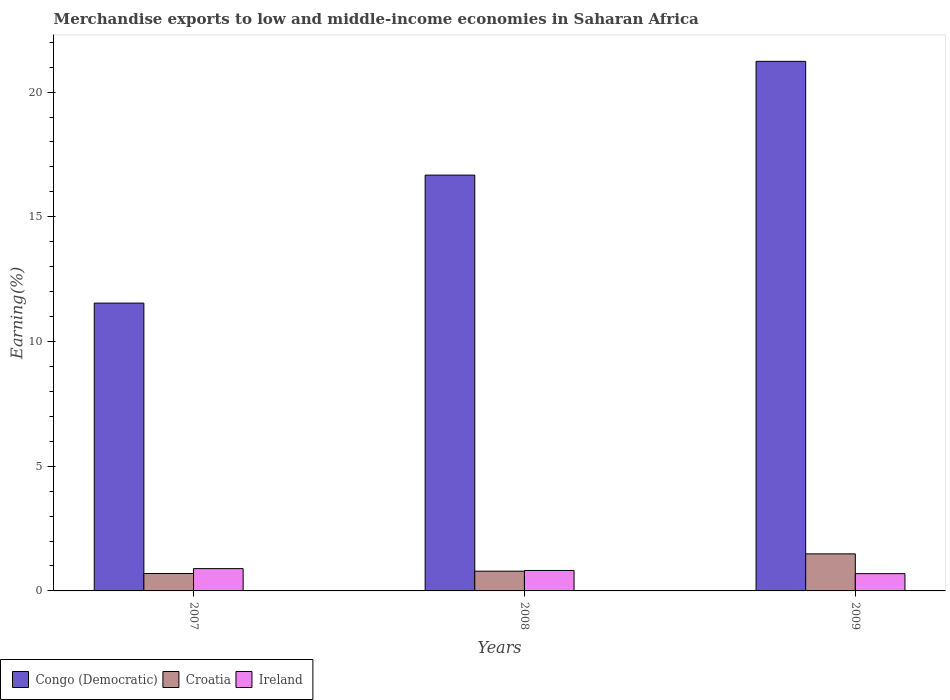How many groups of bars are there?
Your answer should be very brief. 3. Are the number of bars per tick equal to the number of legend labels?
Your answer should be very brief. Yes. Are the number of bars on each tick of the X-axis equal?
Your response must be concise. Yes. How many bars are there on the 1st tick from the left?
Offer a terse response. 3. How many bars are there on the 1st tick from the right?
Give a very brief answer. 3. What is the label of the 1st group of bars from the left?
Ensure brevity in your answer.  2007. In how many cases, is the number of bars for a given year not equal to the number of legend labels?
Make the answer very short. 0. What is the percentage of amount earned from merchandise exports in Congo (Democratic) in 2007?
Ensure brevity in your answer.  11.54. Across all years, what is the maximum percentage of amount earned from merchandise exports in Croatia?
Provide a short and direct response. 1.49. Across all years, what is the minimum percentage of amount earned from merchandise exports in Croatia?
Provide a short and direct response. 0.7. What is the total percentage of amount earned from merchandise exports in Congo (Democratic) in the graph?
Make the answer very short. 49.45. What is the difference between the percentage of amount earned from merchandise exports in Congo (Democratic) in 2007 and that in 2009?
Offer a terse response. -9.69. What is the difference between the percentage of amount earned from merchandise exports in Ireland in 2007 and the percentage of amount earned from merchandise exports in Congo (Democratic) in 2009?
Provide a short and direct response. -20.34. What is the average percentage of amount earned from merchandise exports in Croatia per year?
Give a very brief answer. 0.99. In the year 2007, what is the difference between the percentage of amount earned from merchandise exports in Croatia and percentage of amount earned from merchandise exports in Congo (Democratic)?
Make the answer very short. -10.84. What is the ratio of the percentage of amount earned from merchandise exports in Croatia in 2007 to that in 2009?
Offer a very short reply. 0.47. Is the percentage of amount earned from merchandise exports in Ireland in 2007 less than that in 2008?
Ensure brevity in your answer.  No. Is the difference between the percentage of amount earned from merchandise exports in Croatia in 2007 and 2008 greater than the difference between the percentage of amount earned from merchandise exports in Congo (Democratic) in 2007 and 2008?
Offer a very short reply. Yes. What is the difference between the highest and the second highest percentage of amount earned from merchandise exports in Ireland?
Your answer should be very brief. 0.07. What is the difference between the highest and the lowest percentage of amount earned from merchandise exports in Congo (Democratic)?
Your answer should be compact. 9.69. Is the sum of the percentage of amount earned from merchandise exports in Ireland in 2007 and 2009 greater than the maximum percentage of amount earned from merchandise exports in Congo (Democratic) across all years?
Provide a short and direct response. No. What does the 3rd bar from the left in 2009 represents?
Give a very brief answer. Ireland. What does the 1st bar from the right in 2008 represents?
Provide a succinct answer. Ireland. Is it the case that in every year, the sum of the percentage of amount earned from merchandise exports in Croatia and percentage of amount earned from merchandise exports in Congo (Democratic) is greater than the percentage of amount earned from merchandise exports in Ireland?
Keep it short and to the point. Yes. How many bars are there?
Make the answer very short. 9. Are all the bars in the graph horizontal?
Provide a short and direct response. No. How many years are there in the graph?
Provide a succinct answer. 3. Are the values on the major ticks of Y-axis written in scientific E-notation?
Keep it short and to the point. No. Does the graph contain any zero values?
Keep it short and to the point. No. Where does the legend appear in the graph?
Offer a very short reply. Bottom left. How many legend labels are there?
Offer a very short reply. 3. How are the legend labels stacked?
Your answer should be very brief. Horizontal. What is the title of the graph?
Keep it short and to the point. Merchandise exports to low and middle-income economies in Saharan Africa. Does "Kazakhstan" appear as one of the legend labels in the graph?
Offer a very short reply. No. What is the label or title of the X-axis?
Provide a succinct answer. Years. What is the label or title of the Y-axis?
Offer a terse response. Earning(%). What is the Earning(%) in Congo (Democratic) in 2007?
Provide a succinct answer. 11.54. What is the Earning(%) in Croatia in 2007?
Offer a terse response. 0.7. What is the Earning(%) in Ireland in 2007?
Offer a terse response. 0.89. What is the Earning(%) in Congo (Democratic) in 2008?
Ensure brevity in your answer.  16.67. What is the Earning(%) of Croatia in 2008?
Give a very brief answer. 0.79. What is the Earning(%) in Ireland in 2008?
Your response must be concise. 0.82. What is the Earning(%) of Congo (Democratic) in 2009?
Offer a terse response. 21.23. What is the Earning(%) in Croatia in 2009?
Provide a short and direct response. 1.49. What is the Earning(%) in Ireland in 2009?
Your response must be concise. 0.69. Across all years, what is the maximum Earning(%) of Congo (Democratic)?
Your answer should be very brief. 21.23. Across all years, what is the maximum Earning(%) in Croatia?
Provide a short and direct response. 1.49. Across all years, what is the maximum Earning(%) of Ireland?
Your response must be concise. 0.89. Across all years, what is the minimum Earning(%) in Congo (Democratic)?
Ensure brevity in your answer.  11.54. Across all years, what is the minimum Earning(%) of Croatia?
Provide a succinct answer. 0.7. Across all years, what is the minimum Earning(%) of Ireland?
Make the answer very short. 0.69. What is the total Earning(%) in Congo (Democratic) in the graph?
Your answer should be compact. 49.45. What is the total Earning(%) in Croatia in the graph?
Provide a succinct answer. 2.97. What is the total Earning(%) in Ireland in the graph?
Make the answer very short. 2.41. What is the difference between the Earning(%) in Congo (Democratic) in 2007 and that in 2008?
Ensure brevity in your answer.  -5.13. What is the difference between the Earning(%) in Croatia in 2007 and that in 2008?
Offer a very short reply. -0.09. What is the difference between the Earning(%) of Ireland in 2007 and that in 2008?
Keep it short and to the point. 0.07. What is the difference between the Earning(%) in Congo (Democratic) in 2007 and that in 2009?
Your answer should be compact. -9.69. What is the difference between the Earning(%) of Croatia in 2007 and that in 2009?
Keep it short and to the point. -0.79. What is the difference between the Earning(%) of Ireland in 2007 and that in 2009?
Your answer should be compact. 0.2. What is the difference between the Earning(%) of Congo (Democratic) in 2008 and that in 2009?
Your answer should be very brief. -4.56. What is the difference between the Earning(%) in Croatia in 2008 and that in 2009?
Make the answer very short. -0.69. What is the difference between the Earning(%) of Ireland in 2008 and that in 2009?
Offer a terse response. 0.13. What is the difference between the Earning(%) in Congo (Democratic) in 2007 and the Earning(%) in Croatia in 2008?
Ensure brevity in your answer.  10.75. What is the difference between the Earning(%) of Congo (Democratic) in 2007 and the Earning(%) of Ireland in 2008?
Give a very brief answer. 10.72. What is the difference between the Earning(%) of Croatia in 2007 and the Earning(%) of Ireland in 2008?
Your answer should be compact. -0.12. What is the difference between the Earning(%) in Congo (Democratic) in 2007 and the Earning(%) in Croatia in 2009?
Give a very brief answer. 10.05. What is the difference between the Earning(%) in Congo (Democratic) in 2007 and the Earning(%) in Ireland in 2009?
Make the answer very short. 10.85. What is the difference between the Earning(%) in Croatia in 2007 and the Earning(%) in Ireland in 2009?
Offer a very short reply. 0. What is the difference between the Earning(%) of Congo (Democratic) in 2008 and the Earning(%) of Croatia in 2009?
Your answer should be very brief. 15.19. What is the difference between the Earning(%) of Congo (Democratic) in 2008 and the Earning(%) of Ireland in 2009?
Provide a short and direct response. 15.98. What is the difference between the Earning(%) of Croatia in 2008 and the Earning(%) of Ireland in 2009?
Offer a very short reply. 0.1. What is the average Earning(%) of Congo (Democratic) per year?
Your answer should be very brief. 16.48. What is the average Earning(%) of Ireland per year?
Make the answer very short. 0.8. In the year 2007, what is the difference between the Earning(%) of Congo (Democratic) and Earning(%) of Croatia?
Make the answer very short. 10.84. In the year 2007, what is the difference between the Earning(%) of Congo (Democratic) and Earning(%) of Ireland?
Your answer should be compact. 10.65. In the year 2007, what is the difference between the Earning(%) of Croatia and Earning(%) of Ireland?
Provide a succinct answer. -0.2. In the year 2008, what is the difference between the Earning(%) of Congo (Democratic) and Earning(%) of Croatia?
Your answer should be compact. 15.88. In the year 2008, what is the difference between the Earning(%) of Congo (Democratic) and Earning(%) of Ireland?
Your answer should be compact. 15.85. In the year 2008, what is the difference between the Earning(%) in Croatia and Earning(%) in Ireland?
Offer a terse response. -0.03. In the year 2009, what is the difference between the Earning(%) in Congo (Democratic) and Earning(%) in Croatia?
Your answer should be very brief. 19.75. In the year 2009, what is the difference between the Earning(%) of Congo (Democratic) and Earning(%) of Ireland?
Offer a very short reply. 20.54. In the year 2009, what is the difference between the Earning(%) of Croatia and Earning(%) of Ireland?
Ensure brevity in your answer.  0.79. What is the ratio of the Earning(%) in Congo (Democratic) in 2007 to that in 2008?
Your response must be concise. 0.69. What is the ratio of the Earning(%) in Croatia in 2007 to that in 2008?
Provide a short and direct response. 0.88. What is the ratio of the Earning(%) of Ireland in 2007 to that in 2008?
Keep it short and to the point. 1.09. What is the ratio of the Earning(%) of Congo (Democratic) in 2007 to that in 2009?
Offer a very short reply. 0.54. What is the ratio of the Earning(%) of Croatia in 2007 to that in 2009?
Keep it short and to the point. 0.47. What is the ratio of the Earning(%) in Ireland in 2007 to that in 2009?
Your answer should be very brief. 1.29. What is the ratio of the Earning(%) in Congo (Democratic) in 2008 to that in 2009?
Provide a short and direct response. 0.79. What is the ratio of the Earning(%) of Croatia in 2008 to that in 2009?
Give a very brief answer. 0.53. What is the ratio of the Earning(%) in Ireland in 2008 to that in 2009?
Give a very brief answer. 1.18. What is the difference between the highest and the second highest Earning(%) in Congo (Democratic)?
Keep it short and to the point. 4.56. What is the difference between the highest and the second highest Earning(%) of Croatia?
Provide a short and direct response. 0.69. What is the difference between the highest and the second highest Earning(%) in Ireland?
Provide a succinct answer. 0.07. What is the difference between the highest and the lowest Earning(%) in Congo (Democratic)?
Your response must be concise. 9.69. What is the difference between the highest and the lowest Earning(%) of Croatia?
Offer a very short reply. 0.79. What is the difference between the highest and the lowest Earning(%) of Ireland?
Your answer should be very brief. 0.2. 